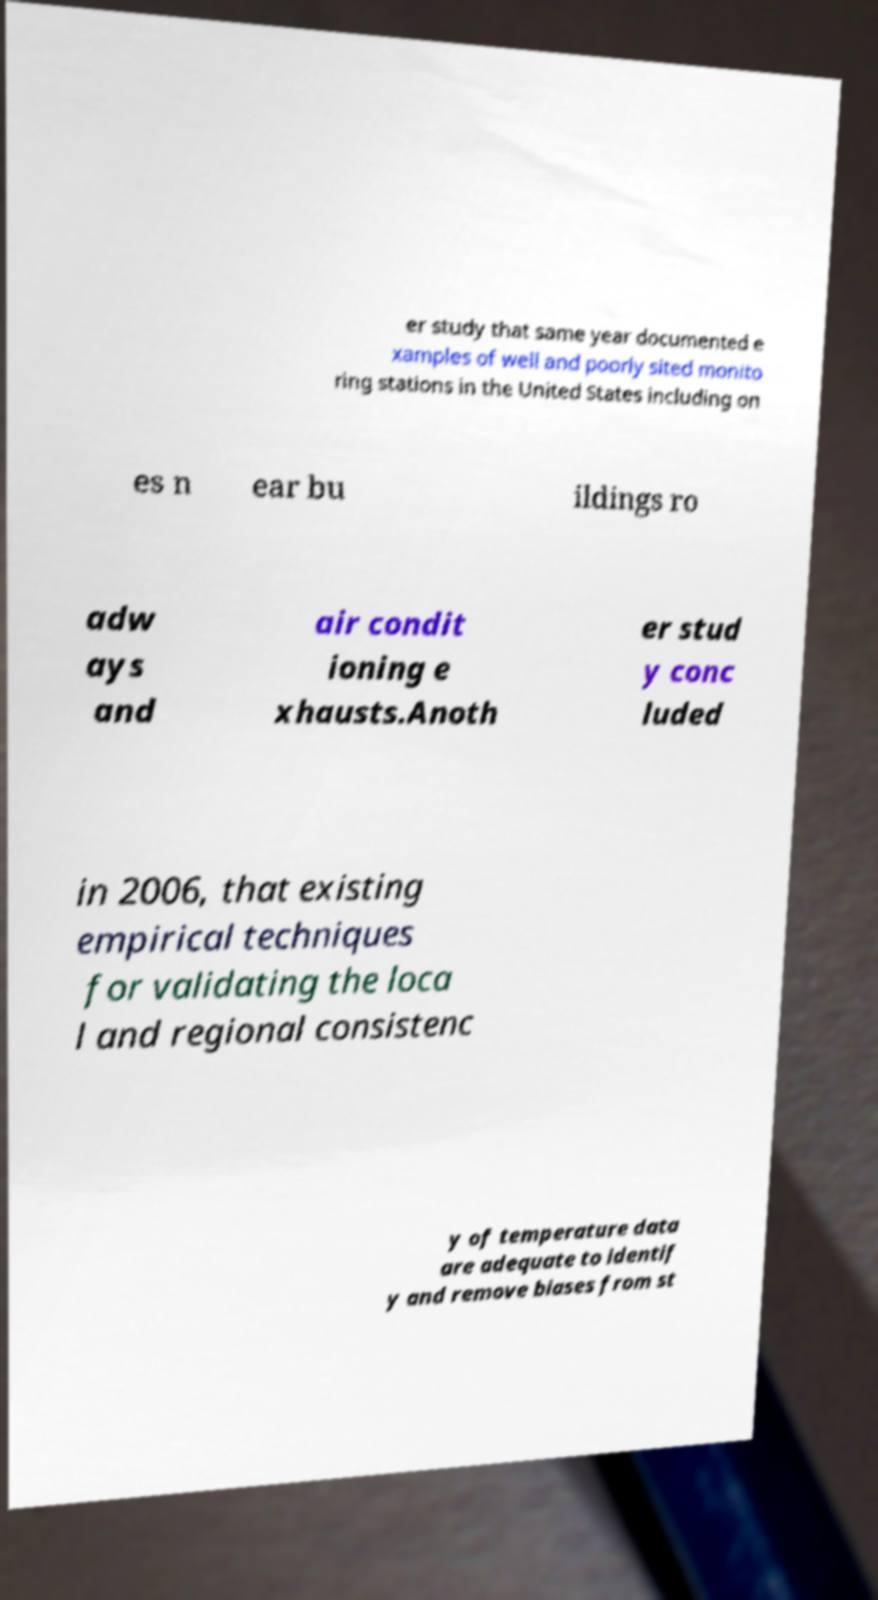Could you assist in decoding the text presented in this image and type it out clearly? er study that same year documented e xamples of well and poorly sited monito ring stations in the United States including on es n ear bu ildings ro adw ays and air condit ioning e xhausts.Anoth er stud y conc luded in 2006, that existing empirical techniques for validating the loca l and regional consistenc y of temperature data are adequate to identif y and remove biases from st 